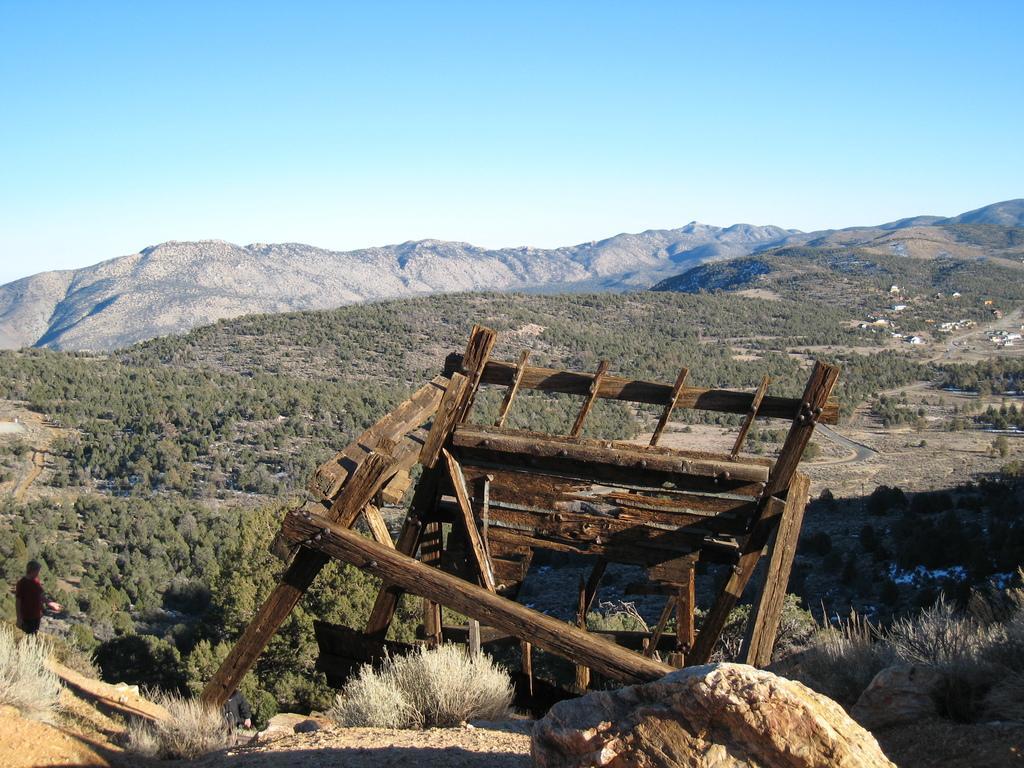Can you describe this image briefly? In this image, there are a few hills, plants. We can also see some grass, a person, a wooden object and the rock. We can also see the sky. 